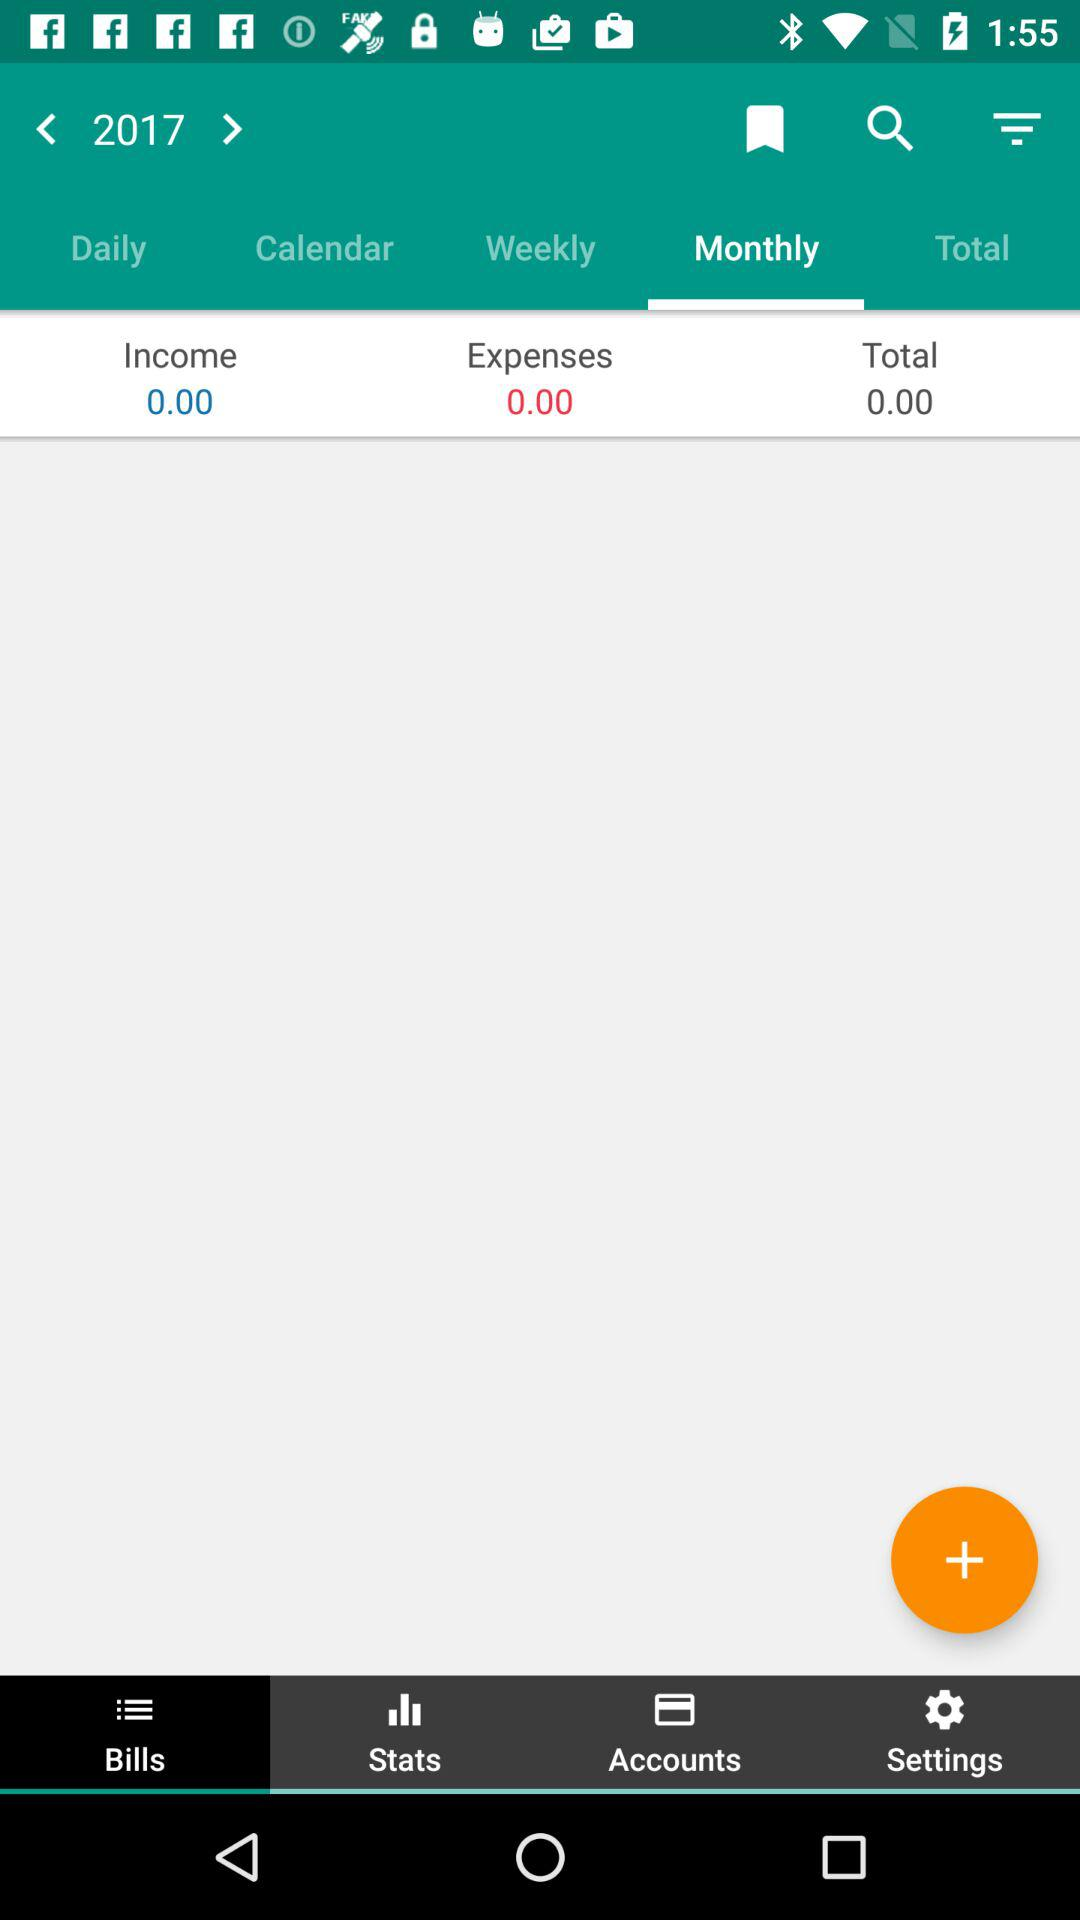What was the amount of expenses? The amount for expenses was 0. 